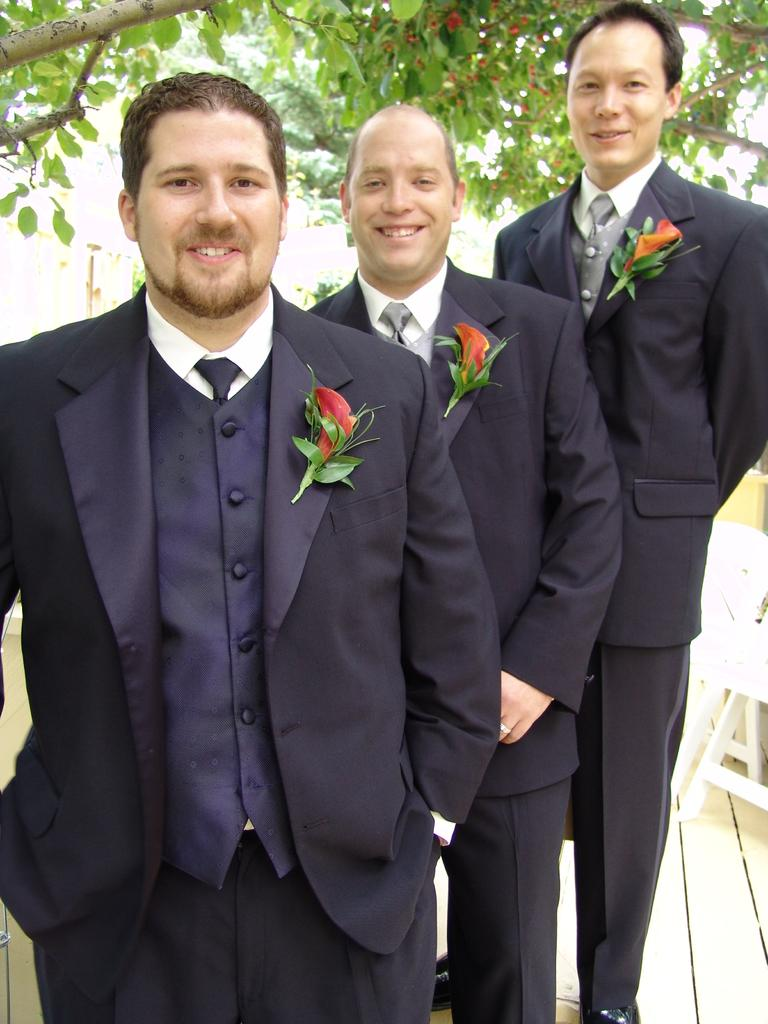How many men are present in the image? There are three men in the image. What is the arrangement of the men in the image? The men are standing one after the other. What type of clothing are the men wearing? Each man is wearing a blazer, a tie, and a shirt. What decorative element is present on the blazers? Flowers are pasted on the blazers. What type of market can be seen in the background of the image? There is no market visible in the image; it only features three men standing one after the other. 